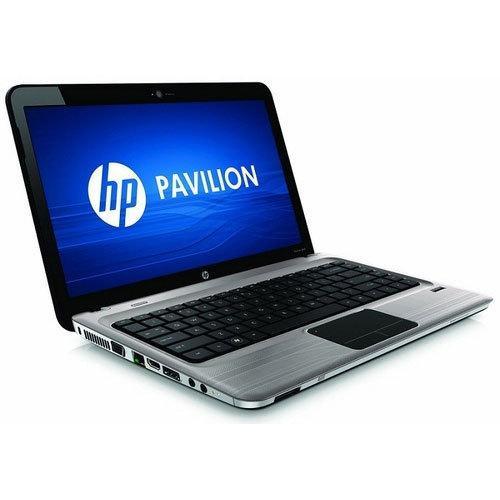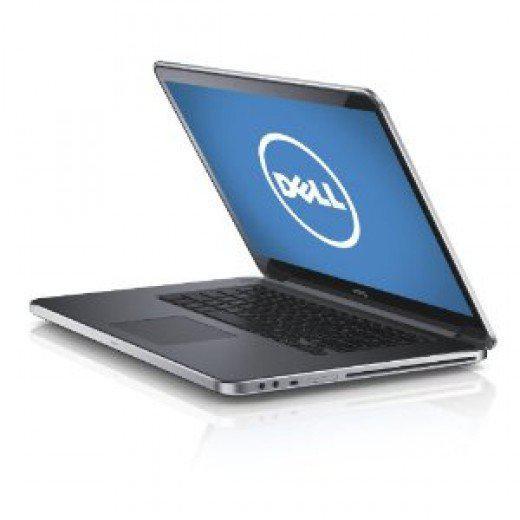The first image is the image on the left, the second image is the image on the right. Considering the images on both sides, is "At least one image shows a partly open laptop with the screen and keyboard forming less than a 90-degree angle." valid? Answer yes or no. Yes. The first image is the image on the left, the second image is the image on the right. Examine the images to the left and right. Is the description "The computers are sitting back to back." accurate? Answer yes or no. No. 